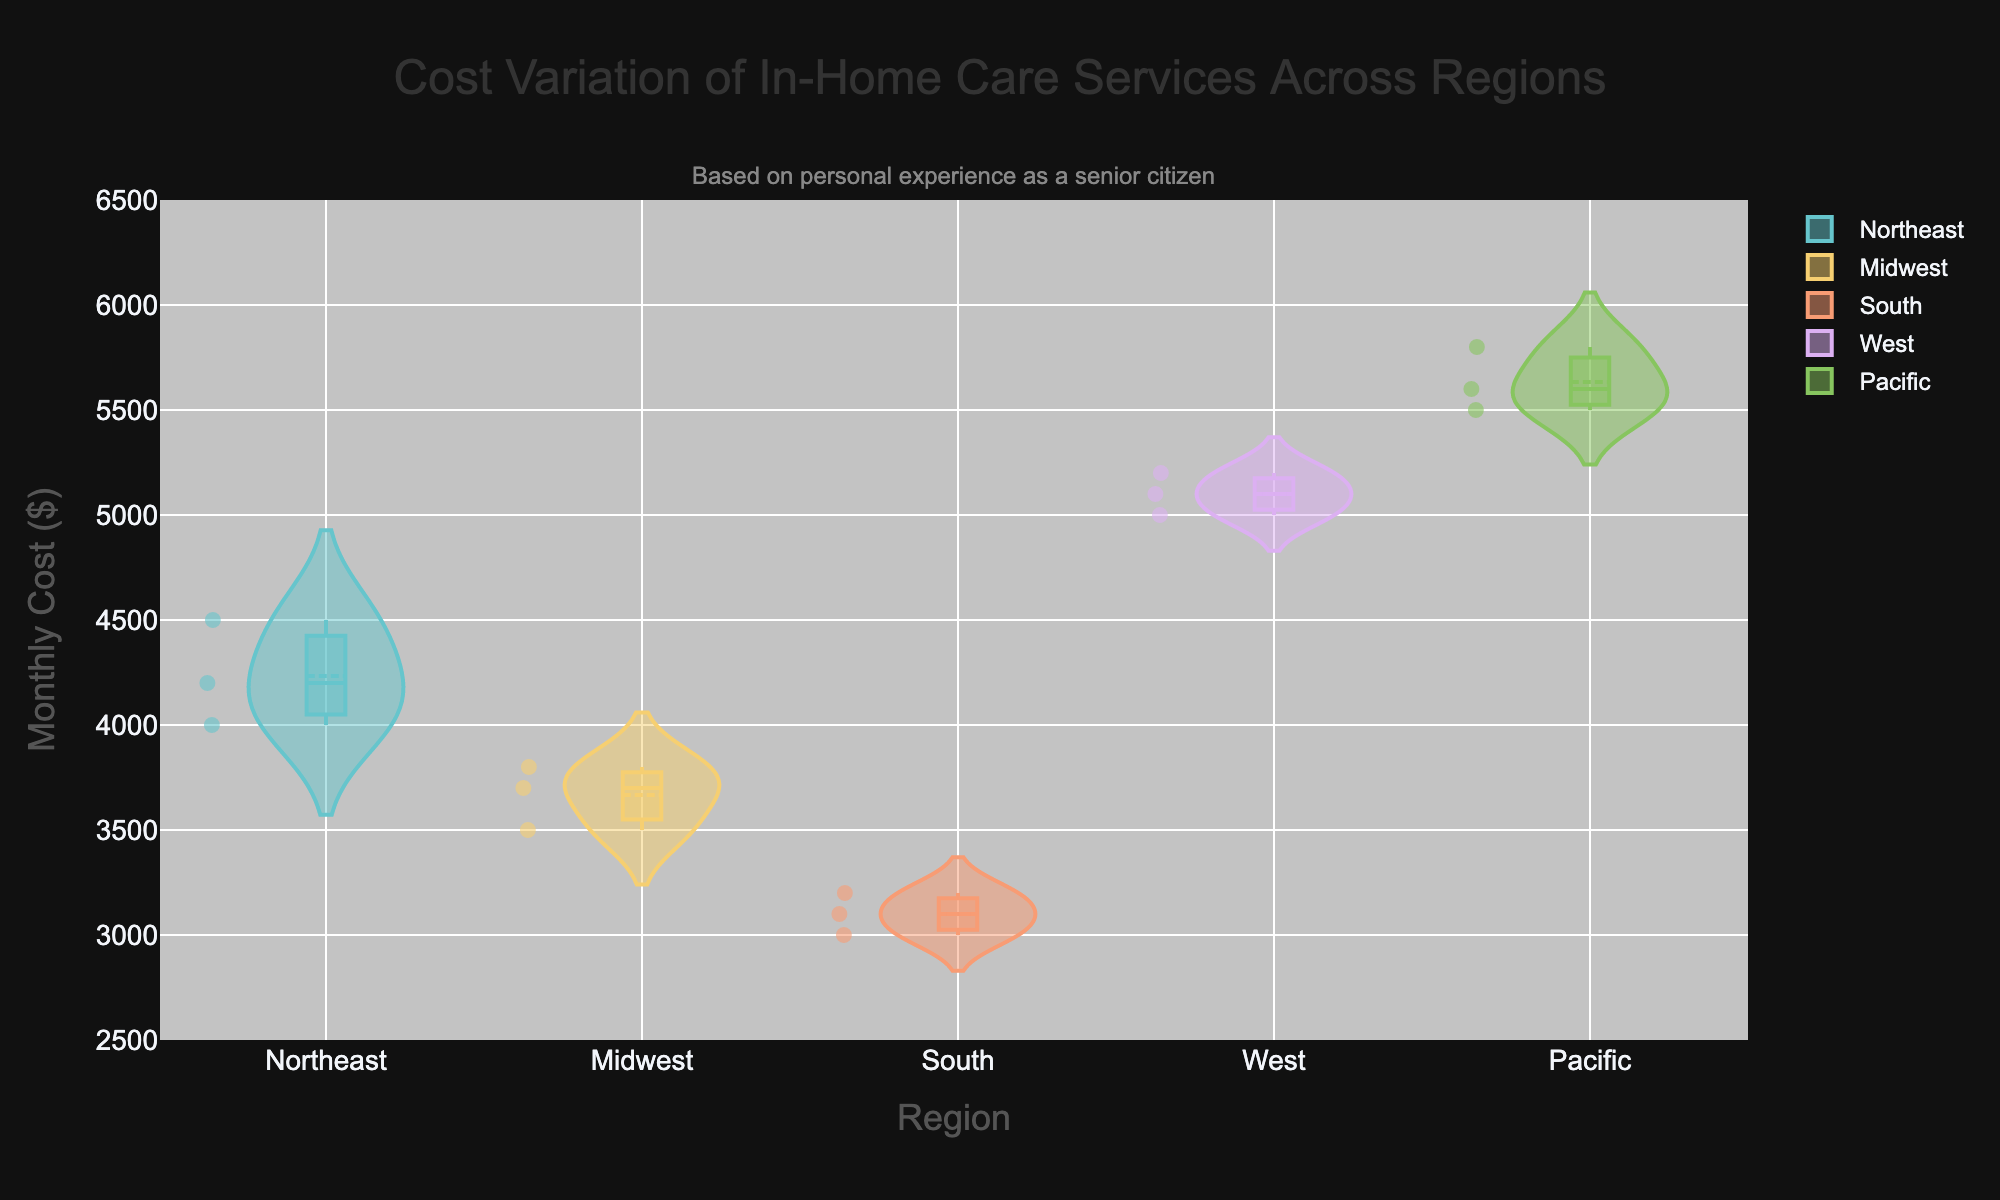What's the highest monthly cost for in-home care in the Pacific region? The Pacific region's data points are 5500, 5800, and 5600. The highest among these is 5800.
Answer: 5800 How many data points are there for the Northeast region? The figure shows that there are three data points for the Northeast region.
Answer: 3 Which region has the lowest average monthly cost for in-home care? Calculate the average for each region and compare:
Northeast: (4000 + 4500 + 4200) / 3 = 4233.33
Midwest: (3500 + 3800 + 3700) / 3 = 3666.67
South: (3000 + 3200 + 3100) / 3 = 3100
West: (5000 + 5200 + 5100) / 3 = 5100
Pacific: (5500 + 5800 + 5600) / 3 = 5633.33
The lowest average is for the South region at 3100.
Answer: South What is the median monthly cost for in-home care in the Midwest region? The Midwest region's data points are 3500, 3800, and 3700. Arranging them in order, we get 3500, 3700, 3800. The median is the middle value, which is 3700.
Answer: 3700 Which region shows the widest spread in monthly costs? The width of a region's violin plot is visually assessed. The Pacific region shows the widest spread between its lowest (5500) and highest (5800) values, giving a spread of 300.
Answer: Pacific How does the average monthly cost for in-home care in the West compare to the Northeast? Calculate and compare the averages:
West: (5000 + 5200 + 5100) / 3 = 5100
Northeast: (4000 + 4500 + 4200) / 3 = 4233.33
5100 - 4233.33 = 866.67
The average monthly cost in the West is higher than the Northeast by 866.67.
Answer: 866.67 higher Which region has the least impact on savings for senior citizens? Impact on savings can be assessed by comparing the median or average values. To simplify, consider the average impact scores:
Northeast: (12 + 14 + 13) / 3 = 13
Midwest: (10 + 11 + 10.5) / 3 = 10.5
South: (9 + 9.5 + 9.3) / 3 = 9.27
West: (15 + 16 + 15.5) / 3 = 15.5
Pacific: (17 + 18 + 17.2) / 3 = 17.4
The South has the least impact on savings with an average of 9.27.
Answer: South Is the maximum monthly cost in the South greater than the minimum monthly cost in the Northeast? The maximum monthly cost in the South is 3200, while the minimum monthly cost in the Northeast is 4000. Since 3200 < 4000, the maximum cost in the South is not greater.
Answer: No 